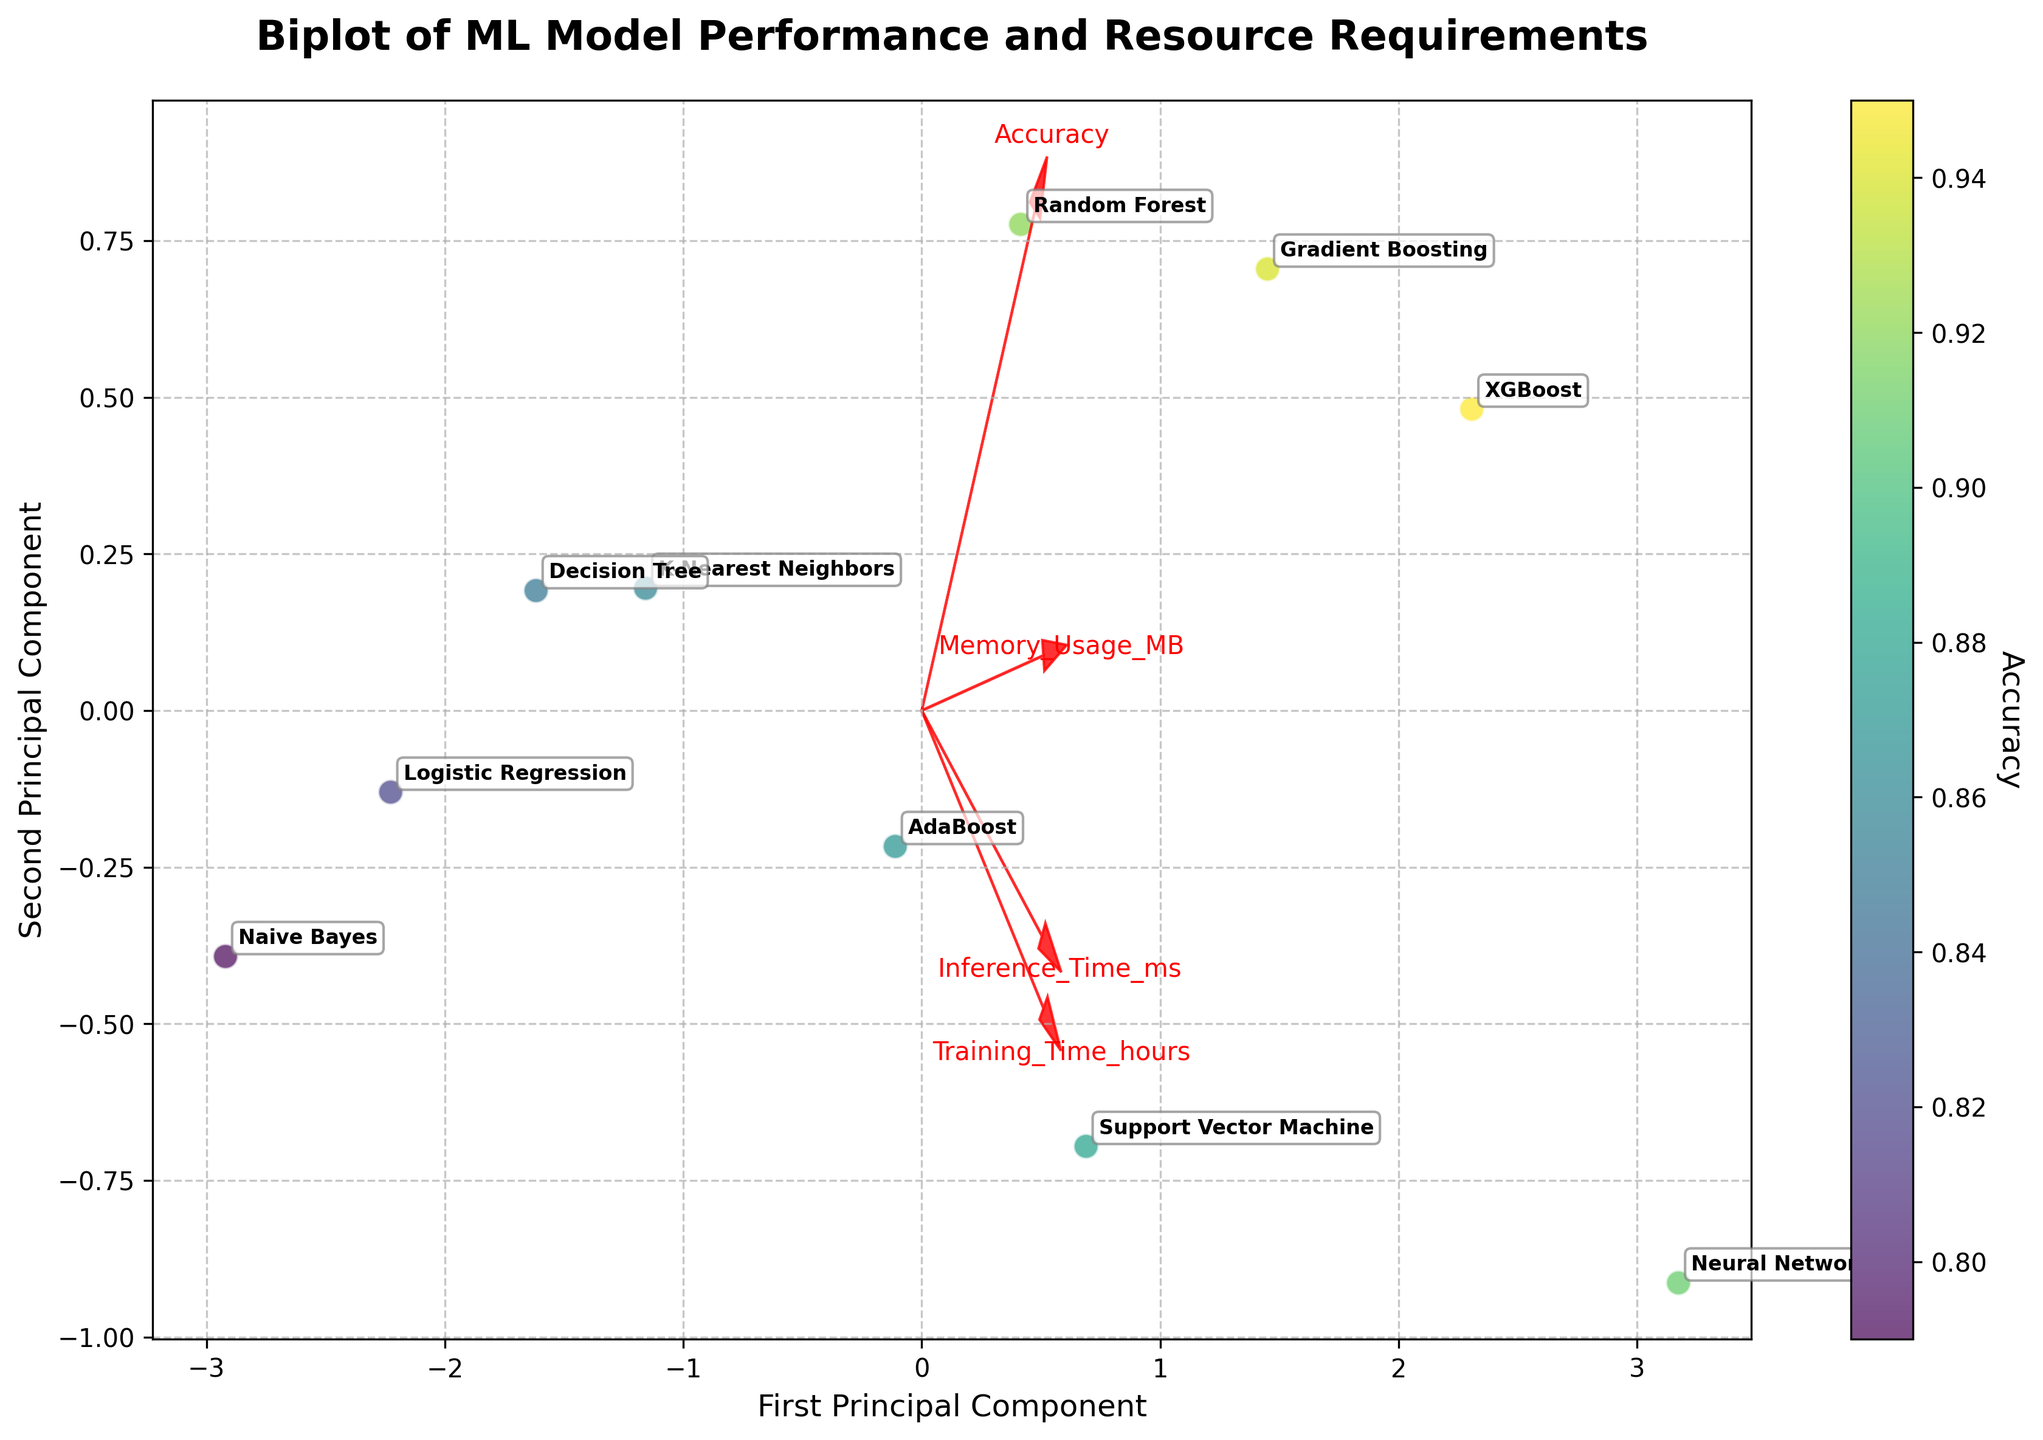What is the title of the biplot? The title of the plot is typically found at the top of the figure. In this case, the title "Biplot of ML Model Performance and Resource Requirements" is clearly displayed.
Answer: Biplot of ML Model Performance and Resource Requirements Which axis represents the first principal component? The labels of the axes indicate what they represent. The x-axis in the figure is labeled as the "First Principal Component."
Answer: x-axis How many models are plotted in the biplot? The number of unique labels in the plot represents the number of models. By counting each label, we can determine that there are 10 models: Random Forest, Support Vector Machine, Gradient Boosting, Neural Network, K-Nearest Neighbors, Decision Tree, XGBoost, Logistic Regression, Naive Bayes, and AdaBoost.
Answer: 10 Which model appears to have the highest accuracy? The accuracy is color-coded in the scatter plot, and the model with the darkest color (highest value on the color bar) represents the highest accuracy. XGBoost appears to have the highest accuracy.
Answer: XGBoost What feature does the arrow pointing furthest to the right represent? The feature vectors in a biplot are shown as arrows. The arrow that points furthest to the right represents the feature that has the highest loading on the first principal component. This arrow represents "Accuracy."
Answer: Accuracy What is the direction of the feature vector for "Training_Time_hours"? Feature vectors are represented as arrows. The direction of the arrow for "Training_Time_hours" in the biplot can be observed directly. It extends towards the lower right part of the plot.
Answer: Lower right Which model has the shortest inference time according to the plot? The inference time is indirectly comprehended by observing other clustering measures and considering that Naive Bayes is closest to "Inference_Time_ms" vector. By verifying the color corresponding to accuracy and location, we see Naive Bayes as having the shortest inference time.
Answer: Naive Bayes Which two models are nearest to each other in the biplot? By visually inspecting the distances between the points, we can identify that the Support Vector Machine and AdaBoost are nearest to each other as they are the closest labeled points in the plot.
Answer: Support Vector Machine and AdaBoost What is the relationship between "Memory_Usage_MB" and "Gradient Boosting" in terms of direction in the biplot? The association can be observed by noting the direction of the feature vector for "Memory_Usage_MB" and comparing it with the location of "Gradient Boosting." The model Gradient Boosting lies somewhat in the direction towards the upper right where "Memory_Usage_MB" vector points.
Answer: Upper right Which principal component does the "Inference_Time_ms" vector load higher on? By observing where the "Inference_Time_ms" vector extends more prominently, we see it extends more in the vertical direction, which corresponds to the second principal component (y-axis).
Answer: Second principal component 